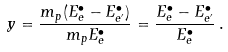Convert formula to latex. <formula><loc_0><loc_0><loc_500><loc_500>y = \frac { m _ { p } ( E ^ { \bullet } _ { e } - E ^ { \bullet } _ { e ^ { \prime } } ) } { m _ { p } E ^ { \bullet } _ { e } } = \frac { E ^ { \bullet } _ { e } - E ^ { \bullet } _ { e ^ { \prime } } } { E ^ { \bullet } _ { e } } \, .</formula> 